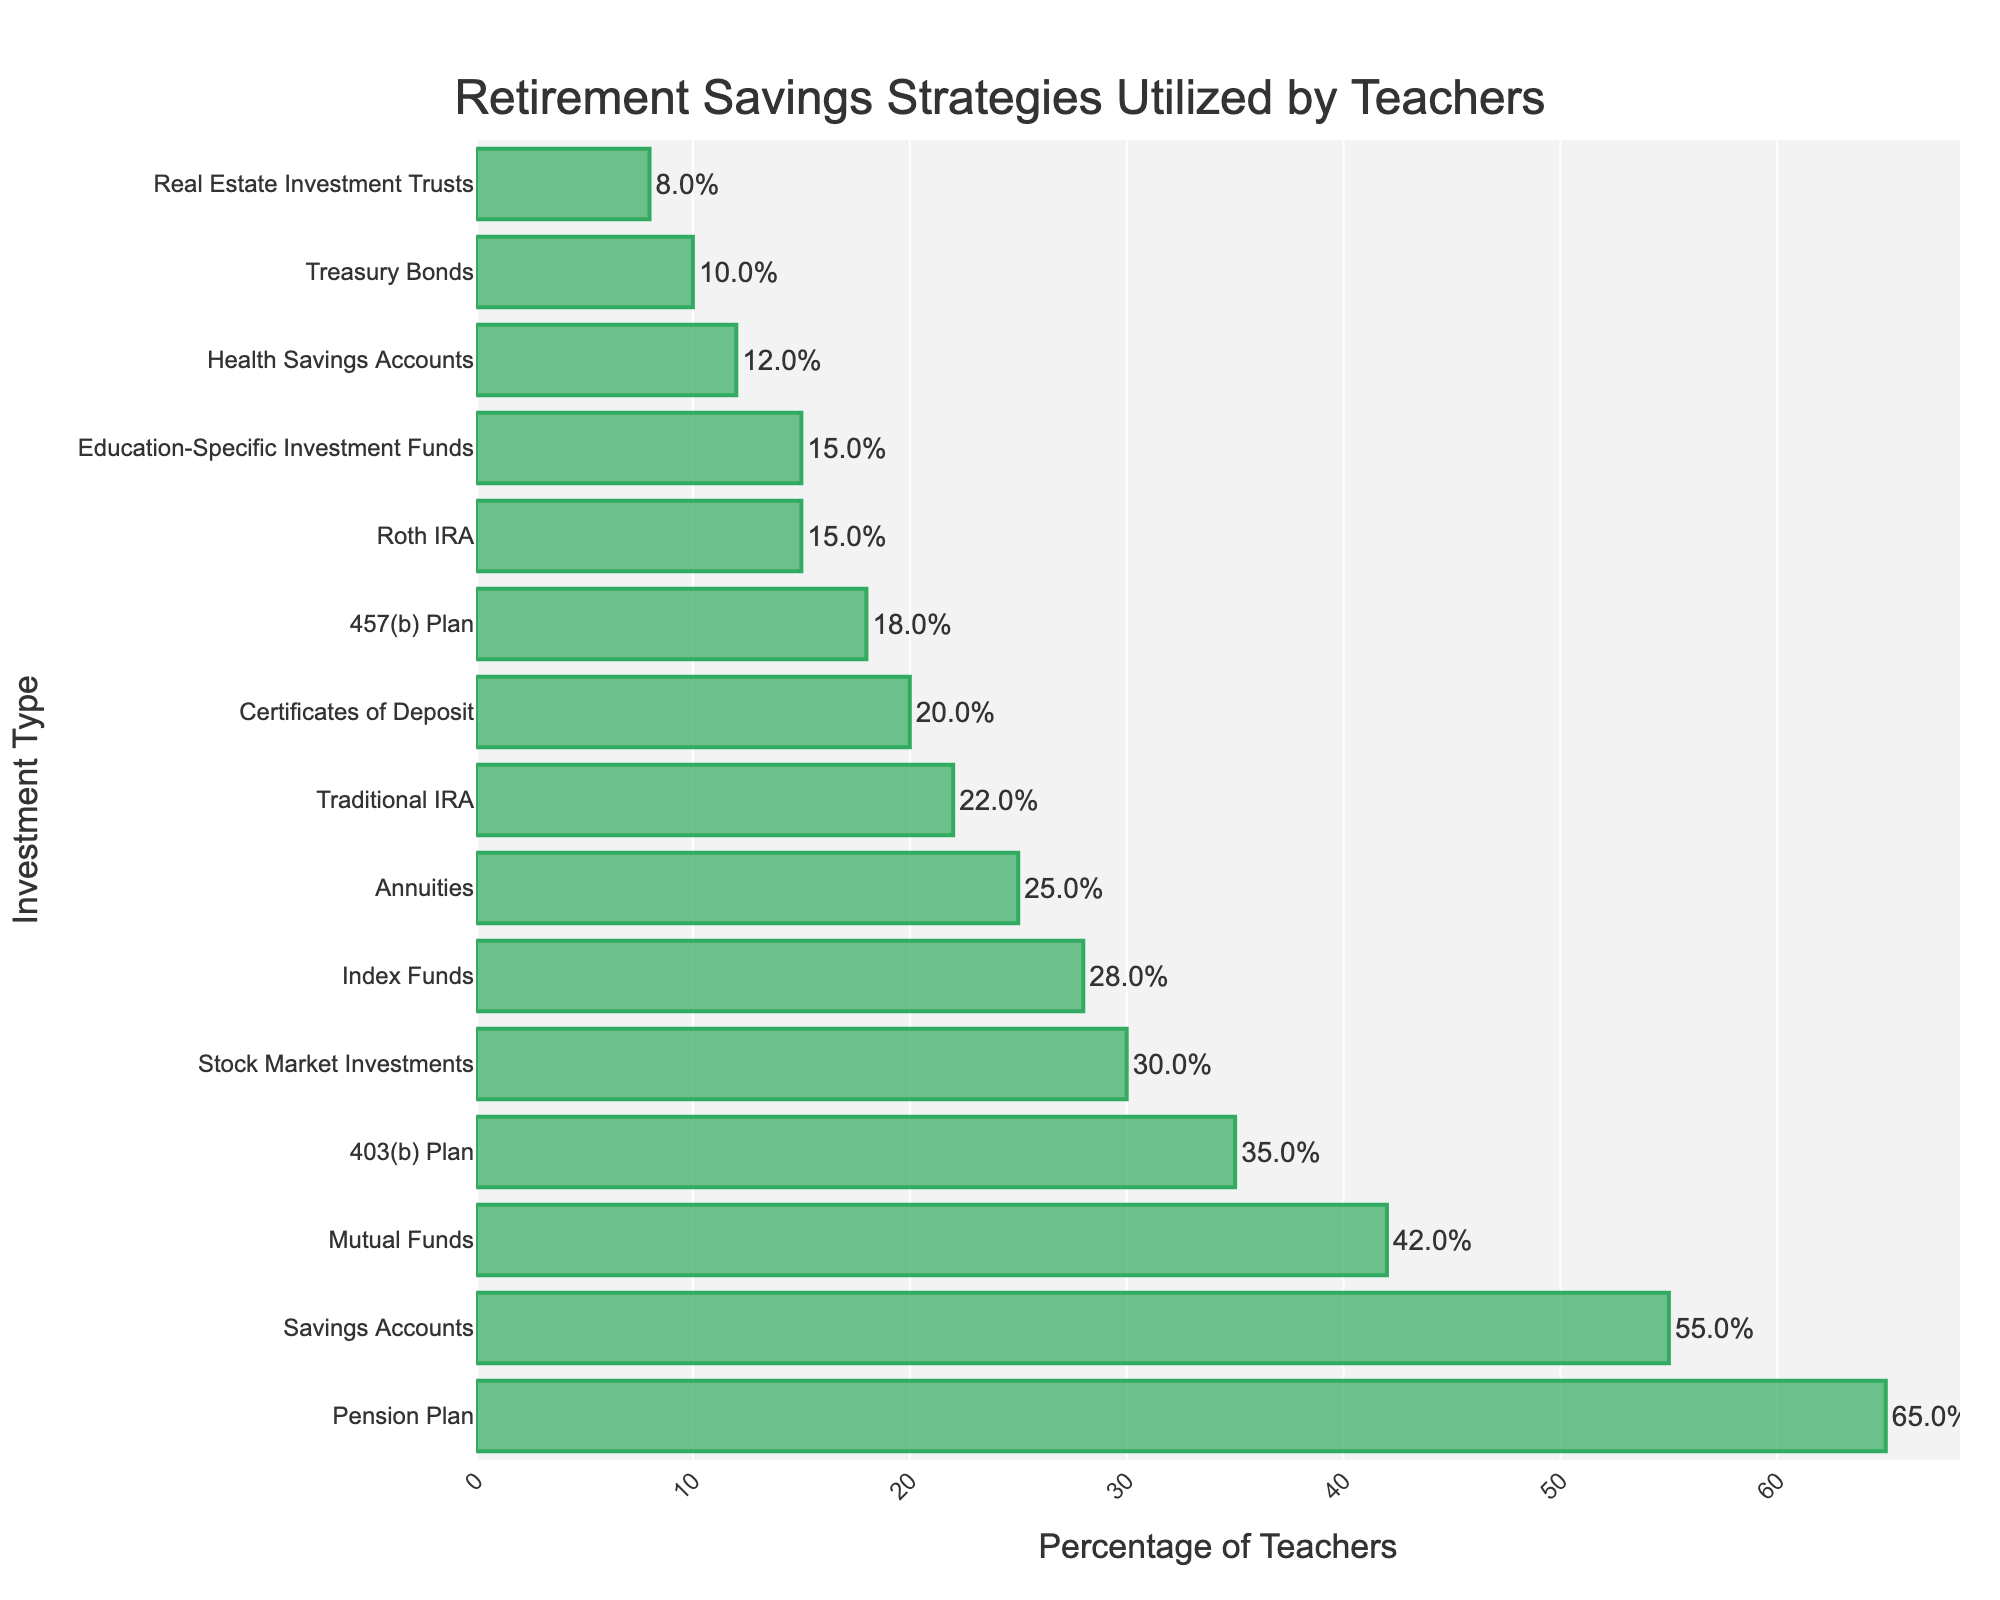what percentage of teachers use Savings Accounts as a retirement strategy? Locate the bar that represents "Savings Accounts" in the chart. The length of the bar should have a percentage label on it.
Answer: 55% which investment type has the highest utilization among teachers? Identify the bar with the maximum length in the chart. The label corresponding to this longest bar will indicate the most utilized investment type.
Answer: Pension Plan what is the difference in usage between 403(b) Plans and 457(b) Plans? Locate the bars for "403(b) Plan" and "457(b) Plan". Note their percentage values and subtract the smaller percentage from the larger one: 35% - 18% = 17%.
Answer: 17% how many investment types are utilized by at least 20% of teachers? Count the number of bars that represent percentage values equal to or greater than 20%. There are 9 such bars.
Answer: 9 which form of IRA is more popular among teachers, Traditional IRA or Roth IRA? Compare the bars representing "Traditional IRA" and "Roth IRA". The bar with the longer length indicates the more popular option. Traditional IRA is at 22% while Roth IRA is at 15%.
Answer: Traditional IRA what is the combined percentage of teachers utilizing Certificates of Deposit and Treasury Bonds? Locate the bars for "Certificates of Deposit" and "Treasury Bonds". Add their respective percentage values: 20% + 10% = 30%.
Answer: 30% compare the percentage usage of Annuities and Mutual Funds. Which is higher and by how much? Identify the bars for "Annuities" and "Mutual Funds". Subtract the smaller percentage (Annuities at 25%) from the larger percentage (Mutual Funds at 42%): 42% - 25% = 17%.
Answer: Mutual Funds by 17% what are the top three most utilized retirement savings strategies? Identify the three longest bars on the chart. The labels for these bars will reveal the top three most utilized strategies. They are Pension Plan (65%), Savings Accounts (55%), and Mutual Funds (42%).
Answer: Pension Plan, Savings Accounts, Mutual Funds which investment type is least utilized by teachers? Find the shortest bar on the chart. The label for this bar will reveal the least utilized investment type. It is "Real Estate Investment Trusts" at 8%.
Answer: Real Estate Investment Trusts 